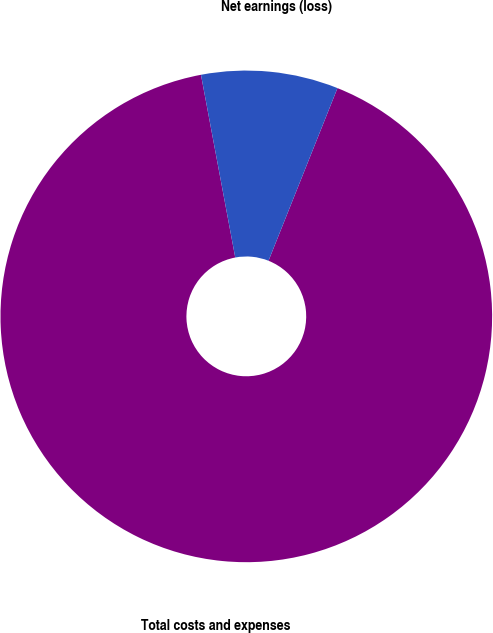<chart> <loc_0><loc_0><loc_500><loc_500><pie_chart><fcel>Total costs and expenses<fcel>Net earnings (loss)<nl><fcel>91.0%<fcel>9.0%<nl></chart> 